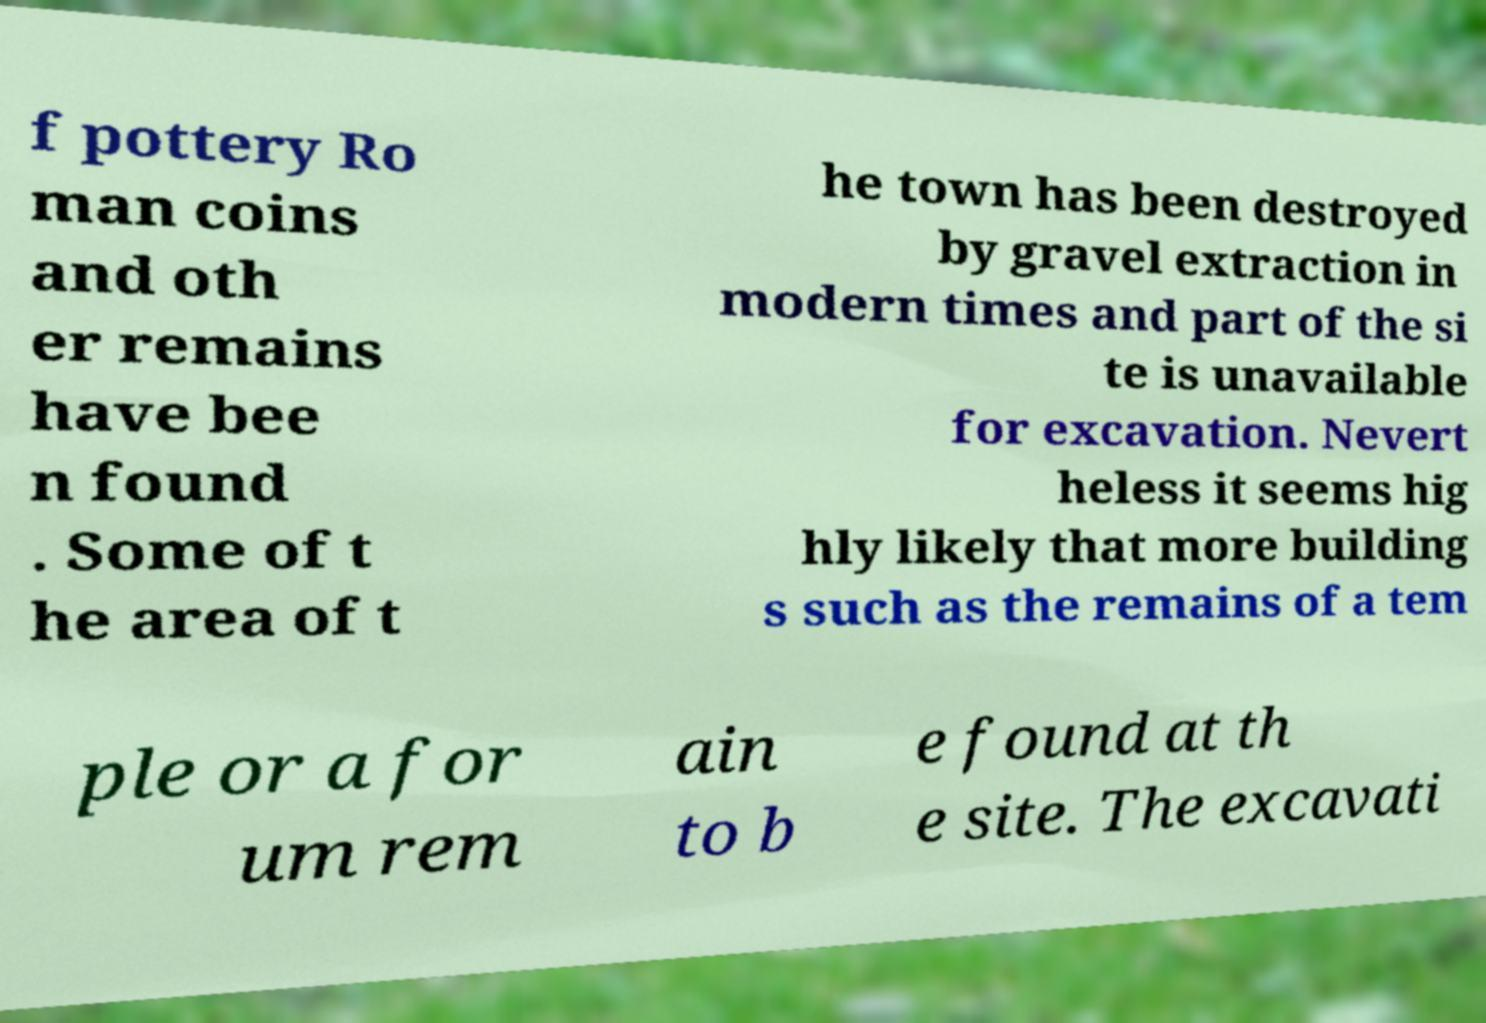I need the written content from this picture converted into text. Can you do that? f pottery Ro man coins and oth er remains have bee n found . Some of t he area of t he town has been destroyed by gravel extraction in modern times and part of the si te is unavailable for excavation. Nevert heless it seems hig hly likely that more building s such as the remains of a tem ple or a for um rem ain to b e found at th e site. The excavati 